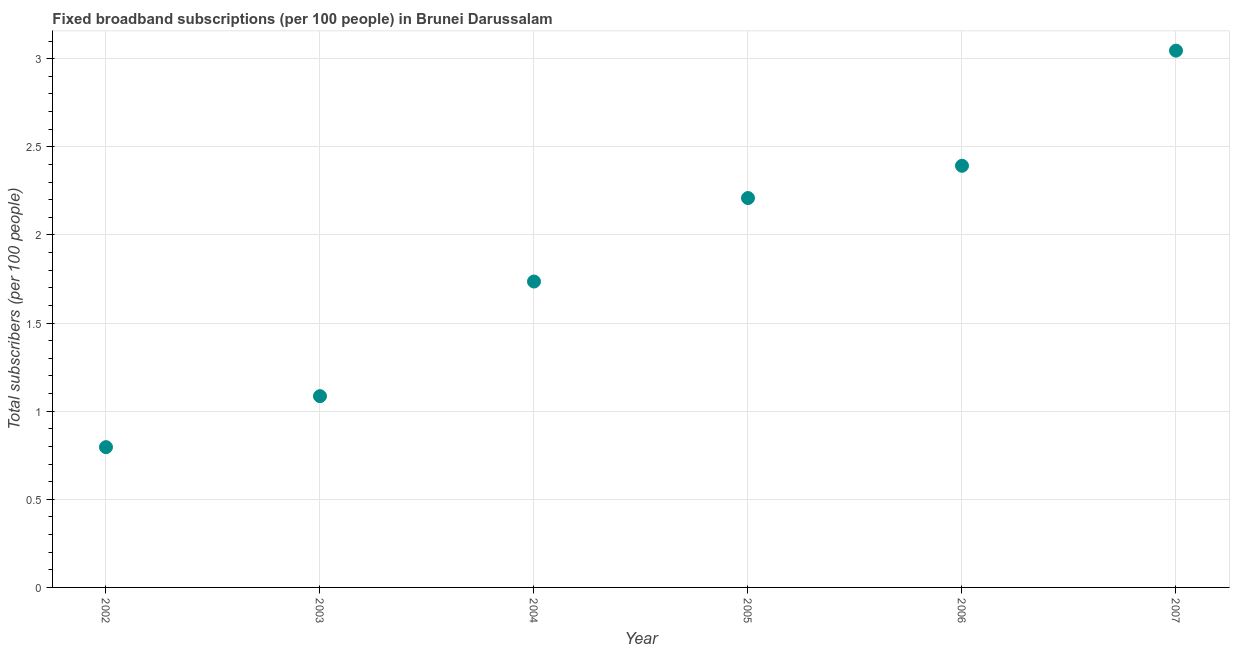What is the total number of fixed broadband subscriptions in 2007?
Keep it short and to the point. 3.05. Across all years, what is the maximum total number of fixed broadband subscriptions?
Give a very brief answer. 3.05. Across all years, what is the minimum total number of fixed broadband subscriptions?
Offer a terse response. 0.8. In which year was the total number of fixed broadband subscriptions maximum?
Your response must be concise. 2007. In which year was the total number of fixed broadband subscriptions minimum?
Ensure brevity in your answer.  2002. What is the sum of the total number of fixed broadband subscriptions?
Make the answer very short. 11.26. What is the difference between the total number of fixed broadband subscriptions in 2003 and 2004?
Provide a succinct answer. -0.65. What is the average total number of fixed broadband subscriptions per year?
Give a very brief answer. 1.88. What is the median total number of fixed broadband subscriptions?
Provide a succinct answer. 1.97. In how many years, is the total number of fixed broadband subscriptions greater than 2.9 ?
Offer a terse response. 1. Do a majority of the years between 2002 and 2004 (inclusive) have total number of fixed broadband subscriptions greater than 0.4 ?
Your response must be concise. Yes. What is the ratio of the total number of fixed broadband subscriptions in 2002 to that in 2003?
Offer a terse response. 0.73. Is the total number of fixed broadband subscriptions in 2002 less than that in 2004?
Make the answer very short. Yes. What is the difference between the highest and the second highest total number of fixed broadband subscriptions?
Give a very brief answer. 0.65. What is the difference between the highest and the lowest total number of fixed broadband subscriptions?
Provide a succinct answer. 2.25. In how many years, is the total number of fixed broadband subscriptions greater than the average total number of fixed broadband subscriptions taken over all years?
Give a very brief answer. 3. Does the total number of fixed broadband subscriptions monotonically increase over the years?
Offer a terse response. Yes. What is the difference between two consecutive major ticks on the Y-axis?
Keep it short and to the point. 0.5. Does the graph contain any zero values?
Give a very brief answer. No. What is the title of the graph?
Offer a very short reply. Fixed broadband subscriptions (per 100 people) in Brunei Darussalam. What is the label or title of the X-axis?
Your response must be concise. Year. What is the label or title of the Y-axis?
Your answer should be very brief. Total subscribers (per 100 people). What is the Total subscribers (per 100 people) in 2002?
Offer a very short reply. 0.8. What is the Total subscribers (per 100 people) in 2003?
Keep it short and to the point. 1.09. What is the Total subscribers (per 100 people) in 2004?
Your answer should be compact. 1.74. What is the Total subscribers (per 100 people) in 2005?
Offer a very short reply. 2.21. What is the Total subscribers (per 100 people) in 2006?
Ensure brevity in your answer.  2.39. What is the Total subscribers (per 100 people) in 2007?
Your answer should be very brief. 3.05. What is the difference between the Total subscribers (per 100 people) in 2002 and 2003?
Keep it short and to the point. -0.29. What is the difference between the Total subscribers (per 100 people) in 2002 and 2004?
Your answer should be compact. -0.94. What is the difference between the Total subscribers (per 100 people) in 2002 and 2005?
Your answer should be very brief. -1.41. What is the difference between the Total subscribers (per 100 people) in 2002 and 2006?
Your answer should be very brief. -1.6. What is the difference between the Total subscribers (per 100 people) in 2002 and 2007?
Your answer should be very brief. -2.25. What is the difference between the Total subscribers (per 100 people) in 2003 and 2004?
Make the answer very short. -0.65. What is the difference between the Total subscribers (per 100 people) in 2003 and 2005?
Provide a short and direct response. -1.12. What is the difference between the Total subscribers (per 100 people) in 2003 and 2006?
Offer a very short reply. -1.31. What is the difference between the Total subscribers (per 100 people) in 2003 and 2007?
Provide a short and direct response. -1.96. What is the difference between the Total subscribers (per 100 people) in 2004 and 2005?
Provide a short and direct response. -0.47. What is the difference between the Total subscribers (per 100 people) in 2004 and 2006?
Give a very brief answer. -0.66. What is the difference between the Total subscribers (per 100 people) in 2004 and 2007?
Provide a short and direct response. -1.31. What is the difference between the Total subscribers (per 100 people) in 2005 and 2006?
Your answer should be very brief. -0.18. What is the difference between the Total subscribers (per 100 people) in 2005 and 2007?
Make the answer very short. -0.84. What is the difference between the Total subscribers (per 100 people) in 2006 and 2007?
Your response must be concise. -0.65. What is the ratio of the Total subscribers (per 100 people) in 2002 to that in 2003?
Make the answer very short. 0.73. What is the ratio of the Total subscribers (per 100 people) in 2002 to that in 2004?
Ensure brevity in your answer.  0.46. What is the ratio of the Total subscribers (per 100 people) in 2002 to that in 2005?
Your response must be concise. 0.36. What is the ratio of the Total subscribers (per 100 people) in 2002 to that in 2006?
Offer a very short reply. 0.33. What is the ratio of the Total subscribers (per 100 people) in 2002 to that in 2007?
Offer a very short reply. 0.26. What is the ratio of the Total subscribers (per 100 people) in 2003 to that in 2005?
Your response must be concise. 0.49. What is the ratio of the Total subscribers (per 100 people) in 2003 to that in 2006?
Provide a succinct answer. 0.45. What is the ratio of the Total subscribers (per 100 people) in 2003 to that in 2007?
Your answer should be compact. 0.36. What is the ratio of the Total subscribers (per 100 people) in 2004 to that in 2005?
Give a very brief answer. 0.79. What is the ratio of the Total subscribers (per 100 people) in 2004 to that in 2006?
Provide a succinct answer. 0.72. What is the ratio of the Total subscribers (per 100 people) in 2004 to that in 2007?
Make the answer very short. 0.57. What is the ratio of the Total subscribers (per 100 people) in 2005 to that in 2006?
Make the answer very short. 0.92. What is the ratio of the Total subscribers (per 100 people) in 2005 to that in 2007?
Offer a very short reply. 0.72. What is the ratio of the Total subscribers (per 100 people) in 2006 to that in 2007?
Offer a very short reply. 0.79. 